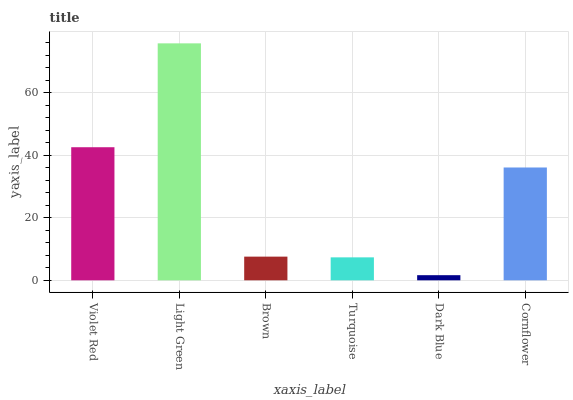Is Dark Blue the minimum?
Answer yes or no. Yes. Is Light Green the maximum?
Answer yes or no. Yes. Is Brown the minimum?
Answer yes or no. No. Is Brown the maximum?
Answer yes or no. No. Is Light Green greater than Brown?
Answer yes or no. Yes. Is Brown less than Light Green?
Answer yes or no. Yes. Is Brown greater than Light Green?
Answer yes or no. No. Is Light Green less than Brown?
Answer yes or no. No. Is Cornflower the high median?
Answer yes or no. Yes. Is Brown the low median?
Answer yes or no. Yes. Is Dark Blue the high median?
Answer yes or no. No. Is Turquoise the low median?
Answer yes or no. No. 